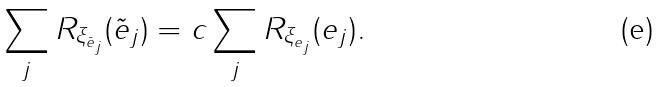Convert formula to latex. <formula><loc_0><loc_0><loc_500><loc_500>\sum _ { j } R _ { \xi _ { \tilde { e } _ { j } } } ( \tilde { e } _ { j } ) = c \sum _ { j } R _ { \xi _ { e _ { j } } } ( e _ { j } ) .</formula> 